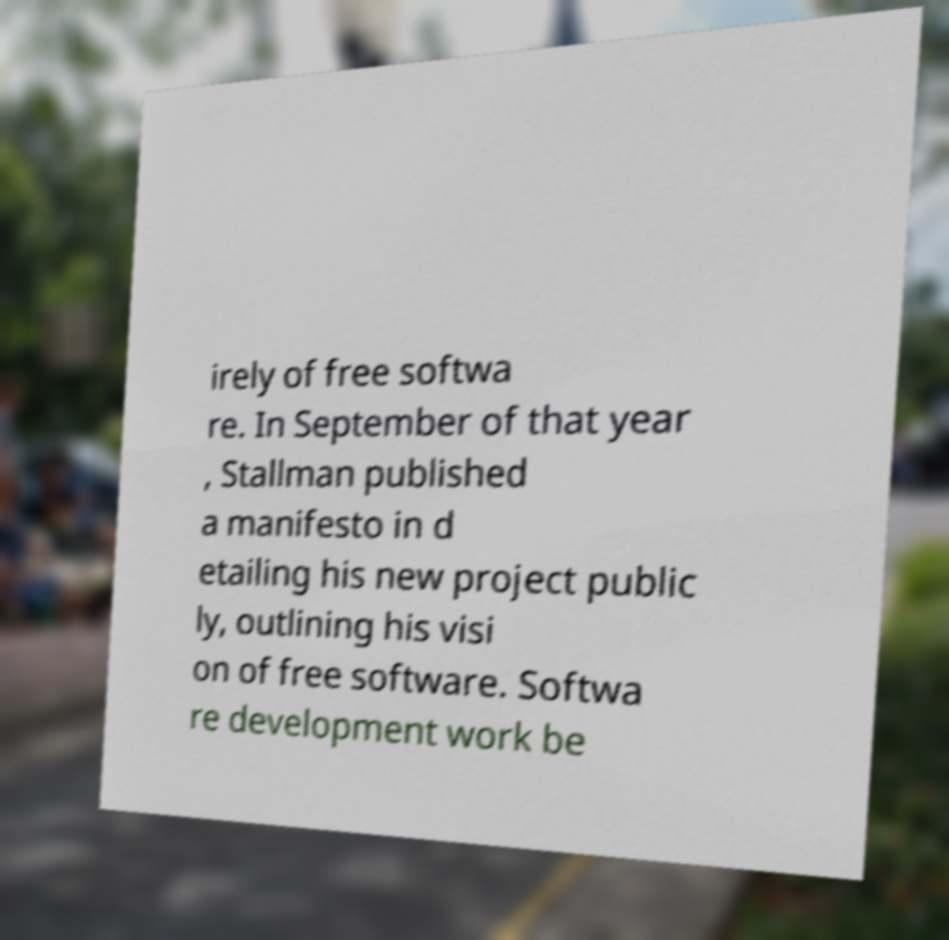For documentation purposes, I need the text within this image transcribed. Could you provide that? irely of free softwa re. In September of that year , Stallman published a manifesto in d etailing his new project public ly, outlining his visi on of free software. Softwa re development work be 